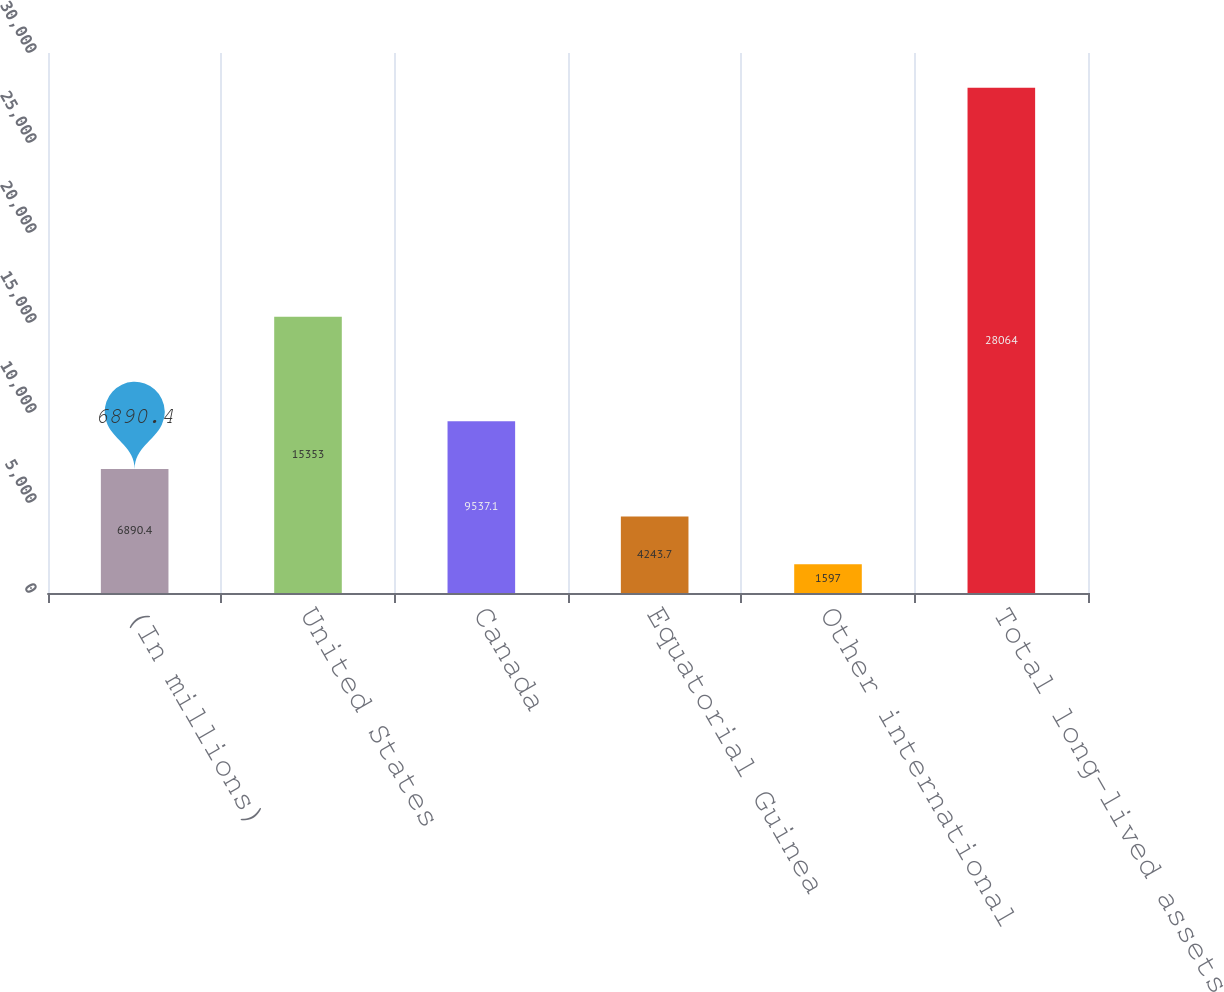Convert chart to OTSL. <chart><loc_0><loc_0><loc_500><loc_500><bar_chart><fcel>(In millions)<fcel>United States<fcel>Canada<fcel>Equatorial Guinea<fcel>Other international<fcel>Total long-lived assets<nl><fcel>6890.4<fcel>15353<fcel>9537.1<fcel>4243.7<fcel>1597<fcel>28064<nl></chart> 